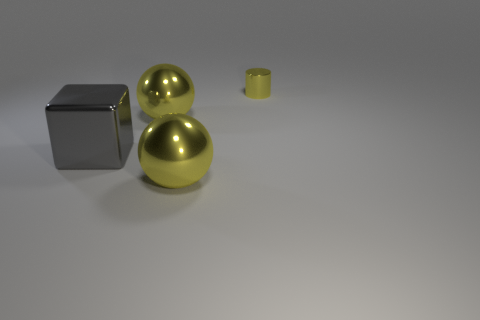Add 1 small yellow shiny objects. How many objects exist? 5 Subtract 1 cylinders. How many cylinders are left? 0 Subtract all red cylinders. Subtract all red spheres. How many cylinders are left? 1 Subtract all big gray shiny cubes. Subtract all yellow shiny cylinders. How many objects are left? 2 Add 4 yellow metallic cylinders. How many yellow metallic cylinders are left? 5 Add 4 yellow shiny cylinders. How many yellow shiny cylinders exist? 5 Subtract 2 yellow balls. How many objects are left? 2 Subtract all cylinders. How many objects are left? 3 